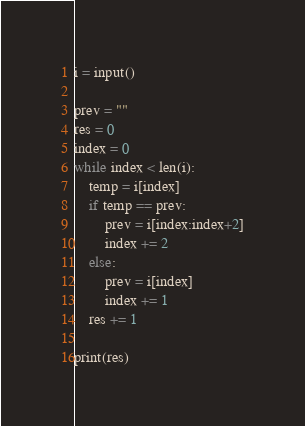<code> <loc_0><loc_0><loc_500><loc_500><_Python_>i = input()

prev = ""
res = 0
index = 0
while index < len(i):
    temp = i[index]
    if temp == prev:
        prev = i[index:index+2]
        index += 2
    else:
        prev = i[index]
        index += 1
    res += 1

print(res)</code> 